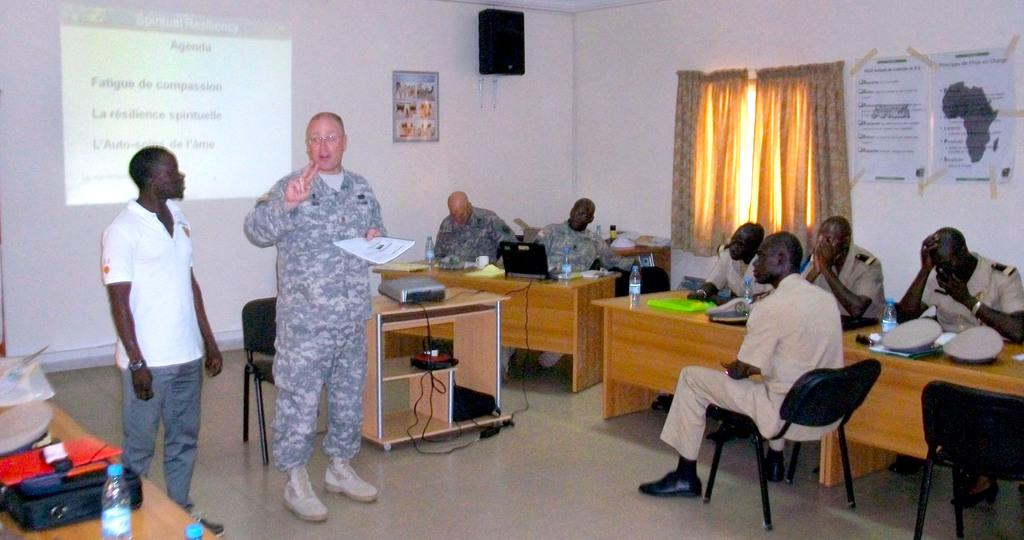Provide a one-sentence caption for the provided image. a meeting between a military and African group with an Agenda sign on the wall. 